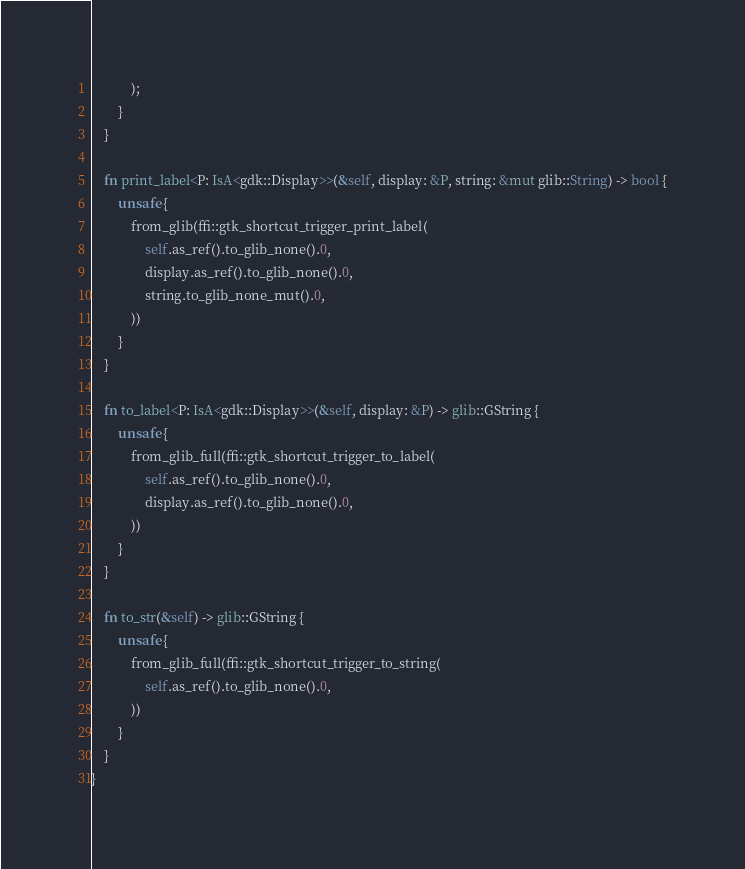<code> <loc_0><loc_0><loc_500><loc_500><_Rust_>            );
        }
    }

    fn print_label<P: IsA<gdk::Display>>(&self, display: &P, string: &mut glib::String) -> bool {
        unsafe {
            from_glib(ffi::gtk_shortcut_trigger_print_label(
                self.as_ref().to_glib_none().0,
                display.as_ref().to_glib_none().0,
                string.to_glib_none_mut().0,
            ))
        }
    }

    fn to_label<P: IsA<gdk::Display>>(&self, display: &P) -> glib::GString {
        unsafe {
            from_glib_full(ffi::gtk_shortcut_trigger_to_label(
                self.as_ref().to_glib_none().0,
                display.as_ref().to_glib_none().0,
            ))
        }
    }

    fn to_str(&self) -> glib::GString {
        unsafe {
            from_glib_full(ffi::gtk_shortcut_trigger_to_string(
                self.as_ref().to_glib_none().0,
            ))
        }
    }
}
</code> 